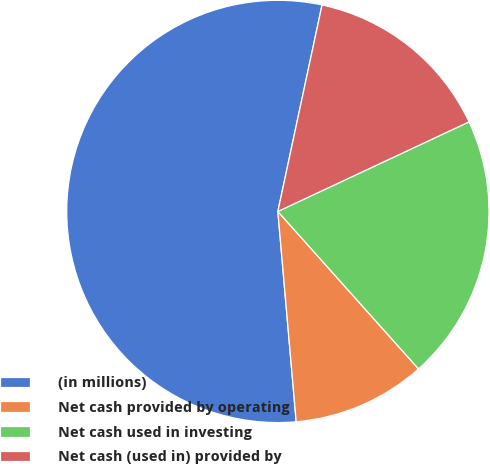Convert chart to OTSL. <chart><loc_0><loc_0><loc_500><loc_500><pie_chart><fcel>(in millions)<fcel>Net cash provided by operating<fcel>Net cash used in investing<fcel>Net cash (used in) provided by<nl><fcel>54.74%<fcel>10.22%<fcel>20.37%<fcel>14.67%<nl></chart> 